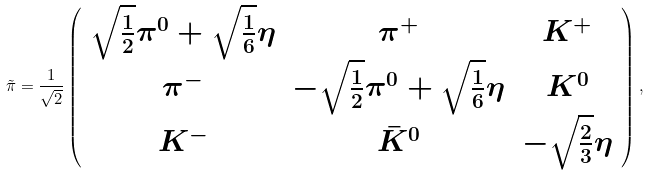<formula> <loc_0><loc_0><loc_500><loc_500>\tilde { \pi } = \frac { 1 } { \sqrt { 2 } } \left ( \begin{array} { c c c } \sqrt { \frac { 1 } { 2 } } \pi ^ { 0 } + \sqrt { \frac { 1 } { 6 } } \eta & \pi ^ { + } & K ^ { + } \\ \pi ^ { - } & - \sqrt { \frac { 1 } { 2 } } \pi ^ { 0 } + \sqrt { \frac { 1 } { 6 } } \eta & K ^ { 0 } \\ K ^ { - } & { \bar { K } } ^ { 0 } & - \sqrt { \frac { 2 } { 3 } } \eta \end{array} \right ) ,</formula> 